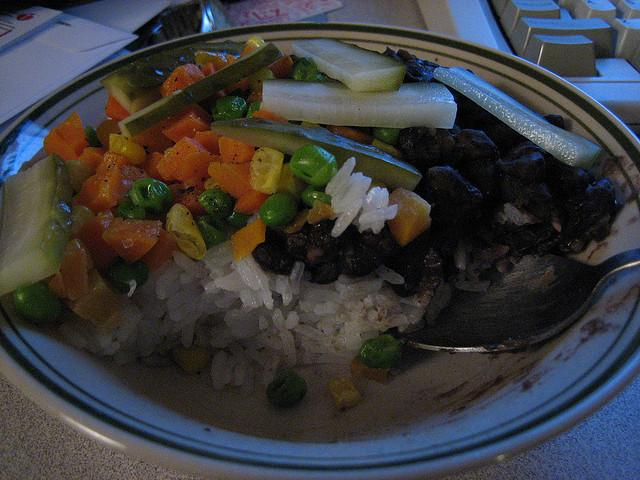What is available on this meal among the following ingredients options? Please explain your reasoning. rice. The other options don't appear here on the plate. 